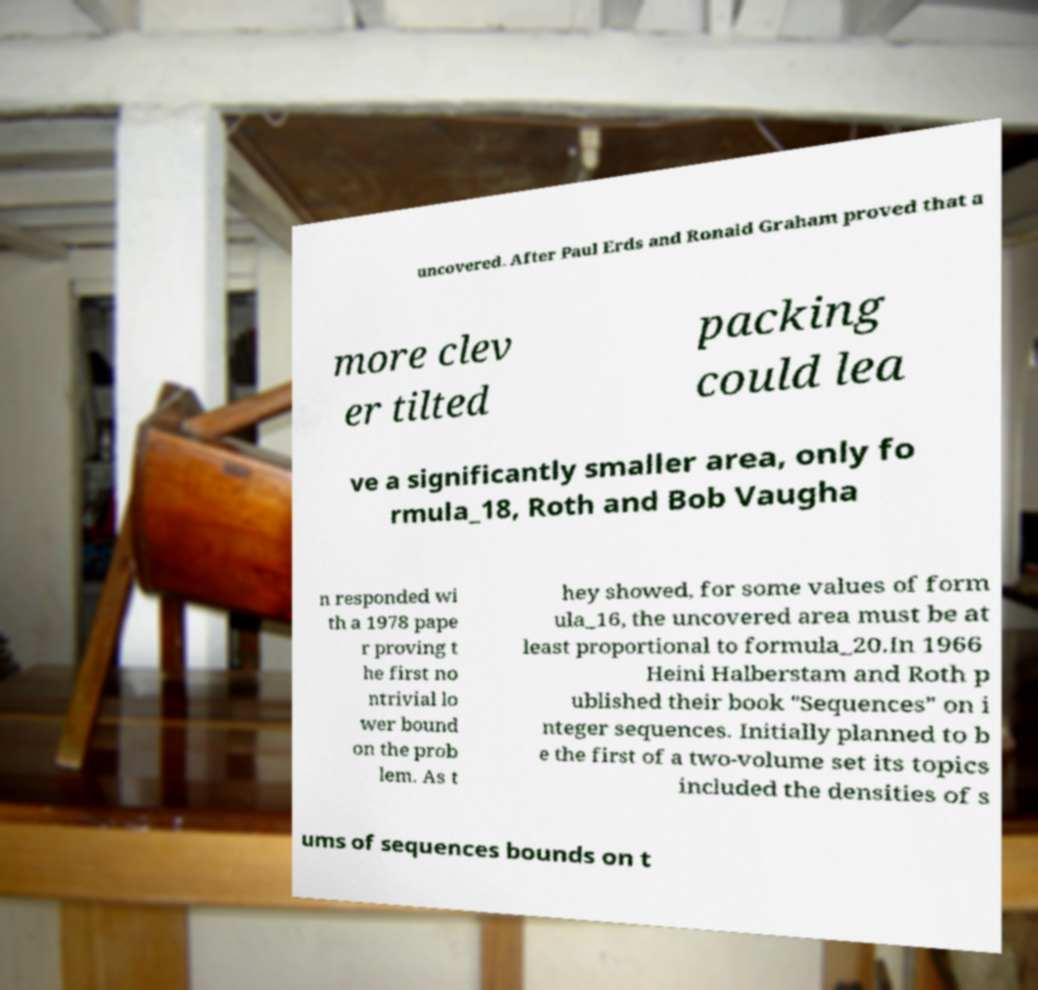Please read and relay the text visible in this image. What does it say? uncovered. After Paul Erds and Ronald Graham proved that a more clev er tilted packing could lea ve a significantly smaller area, only fo rmula_18, Roth and Bob Vaugha n responded wi th a 1978 pape r proving t he first no ntrivial lo wer bound on the prob lem. As t hey showed, for some values of form ula_16, the uncovered area must be at least proportional to formula_20.In 1966 Heini Halberstam and Roth p ublished their book "Sequences" on i nteger sequences. Initially planned to b e the first of a two-volume set its topics included the densities of s ums of sequences bounds on t 